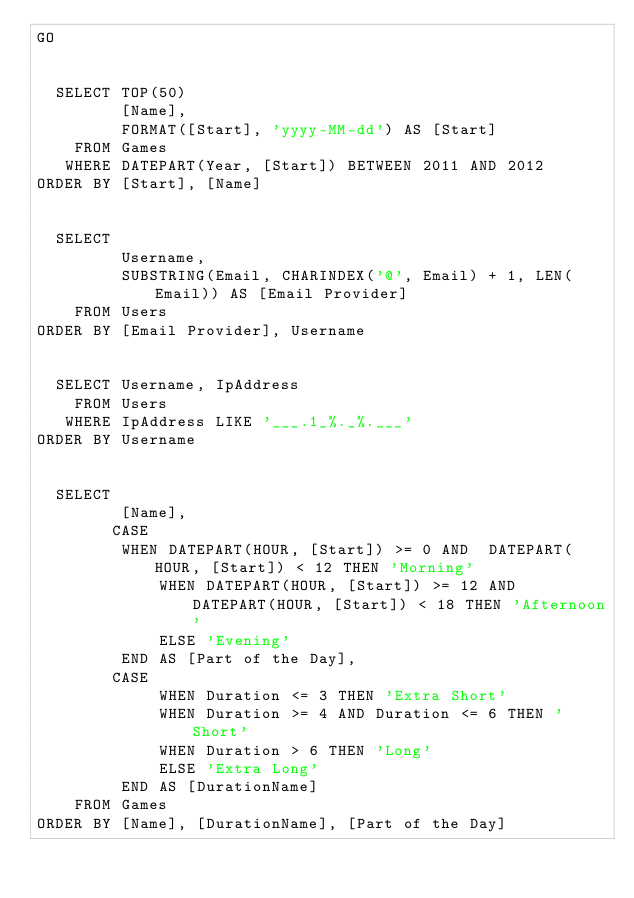Convert code to text. <code><loc_0><loc_0><loc_500><loc_500><_SQL_>GO


  SELECT TOP(50) 
         [Name], 
         FORMAT([Start], 'yyyy-MM-dd') AS [Start]
    FROM Games
   WHERE DATEPART(Year, [Start]) BETWEEN 2011 AND 2012
ORDER BY [Start], [Name]


  SELECT 
         Username, 
         SUBSTRING(Email, CHARINDEX('@', Email) + 1, LEN(Email)) AS [Email Provider]
    FROM Users
ORDER BY [Email Provider], Username


  SELECT Username, IpAddress
    FROM Users
   WHERE IpAddress LIKE '___.1_%._%.___'
ORDER BY Username


  SELECT 
         [Name], 
        CASE
	     WHEN DATEPART(HOUR, [Start]) >= 0 AND  DATEPART(HOUR, [Start]) < 12 THEN 'Morning'
             WHEN DATEPART(HOUR, [Start]) >= 12 AND  DATEPART(HOUR, [Start]) < 18 THEN 'Afternoon'
             ELSE 'Evening'
         END AS [Part of the Day],
        CASE
             WHEN Duration <= 3 THEN 'Extra Short'
             WHEN Duration >= 4 AND Duration <= 6 THEN 'Short'
             WHEN Duration > 6 THEN 'Long'
             ELSE 'Extra Long'
         END AS [DurationName]
    FROM Games
ORDER BY [Name], [DurationName], [Part of the Day]
</code> 